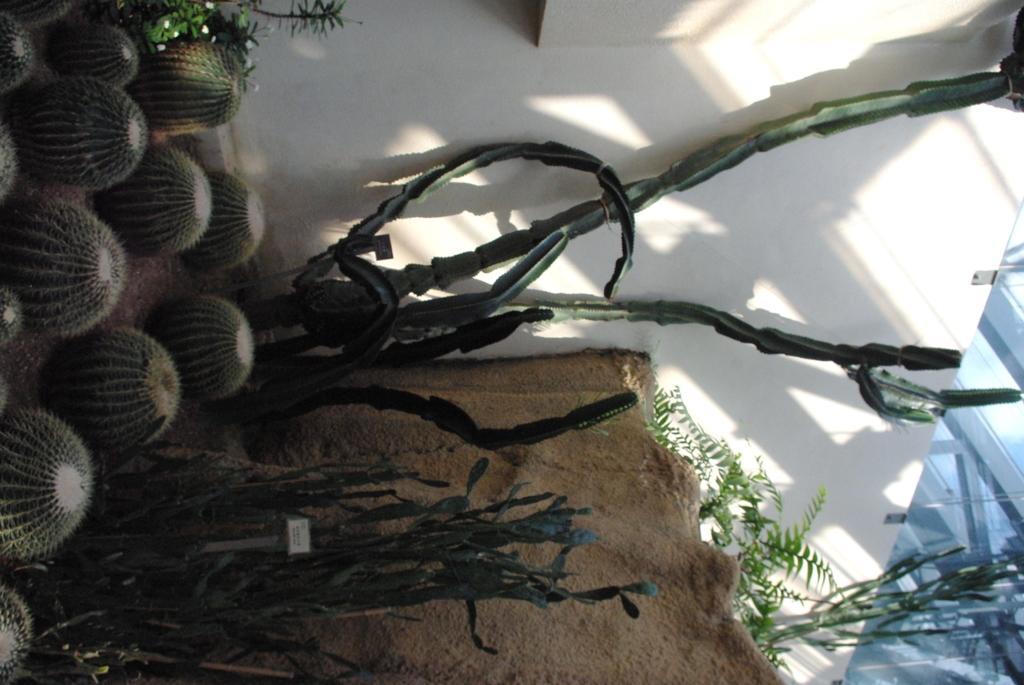What type of plants are in the image? There are cactus plants in the image. What other objects can be seen in the image? There is a rock and a glass in the image. What is the background of the image made of? There is a white wall in the image. What type of bone can be seen in the image? There is no bone present in the image. Is there a cushion on the rock in the image? There is no cushion mentioned or visible in the image. 